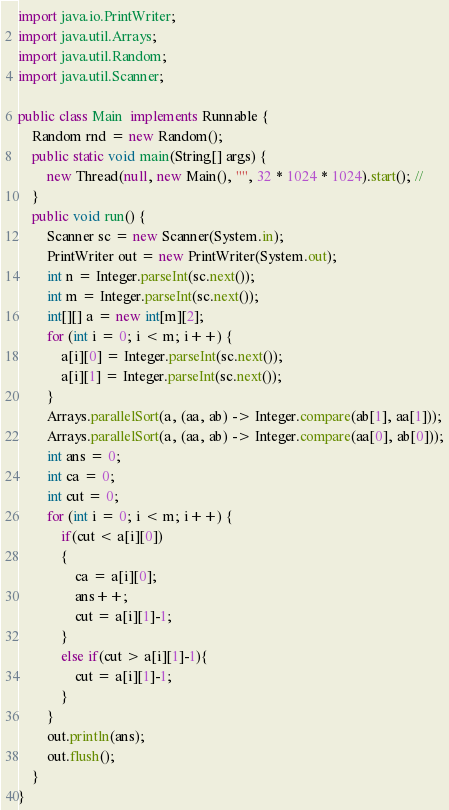Convert code to text. <code><loc_0><loc_0><loc_500><loc_500><_Java_>import java.io.PrintWriter;
import java.util.Arrays;
import java.util.Random;
import java.util.Scanner;

public class Main  implements Runnable {
	Random rnd = new Random();
	public static void main(String[] args) {
		new Thread(null, new Main(), "", 32 * 1024 * 1024).start(); //
	}
	public void run() {
		Scanner sc = new Scanner(System.in);
		PrintWriter out = new PrintWriter(System.out);
		int n = Integer.parseInt(sc.next());
		int m = Integer.parseInt(sc.next());
		int[][] a = new int[m][2];
		for (int i = 0; i < m; i++) {
			a[i][0] = Integer.parseInt(sc.next());
			a[i][1] = Integer.parseInt(sc.next());
		}
		Arrays.parallelSort(a, (aa, ab) -> Integer.compare(ab[1], aa[1]));
		Arrays.parallelSort(a, (aa, ab) -> Integer.compare(aa[0], ab[0]));
		int ans = 0;
		int ca = 0;
		int cut = 0;
		for (int i = 0; i < m; i++) {
			if(cut < a[i][0])
			{
				ca = a[i][0];
				ans++;
				cut = a[i][1]-1;
			}
			else if(cut > a[i][1]-1){
				cut = a[i][1]-1;
			}
		}
		out.println(ans);
		out.flush();
	}
}</code> 